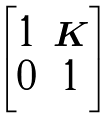<formula> <loc_0><loc_0><loc_500><loc_500>\begin{bmatrix} 1 & K \\ 0 & 1 \end{bmatrix}</formula> 